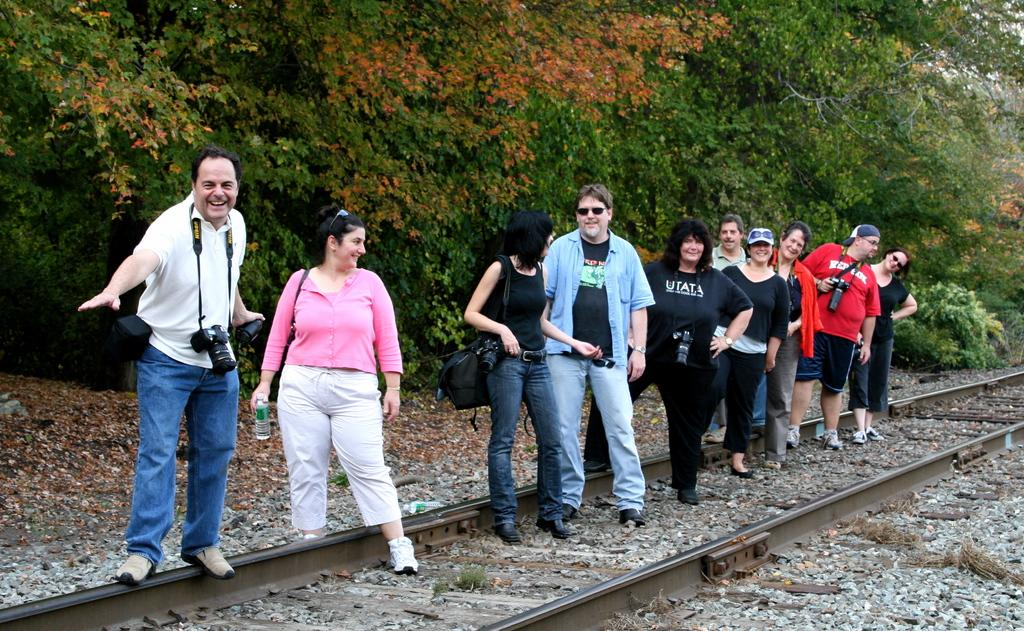What are the people in the image doing? The people in the image are standing in the center. What is located at the bottom of the image? There is a railway track at the bottom of the image. What type of natural elements can be seen in the image? Stones are visible in the image. What can be seen in the distance in the image? There are trees in the background of the image. What type of pear is hanging from the tree in the image? There is no pear or tree present in the image. How many stars can be seen in the sky in the image? The image does not show the sky, so it is not possible to determine if any stars are visible. 